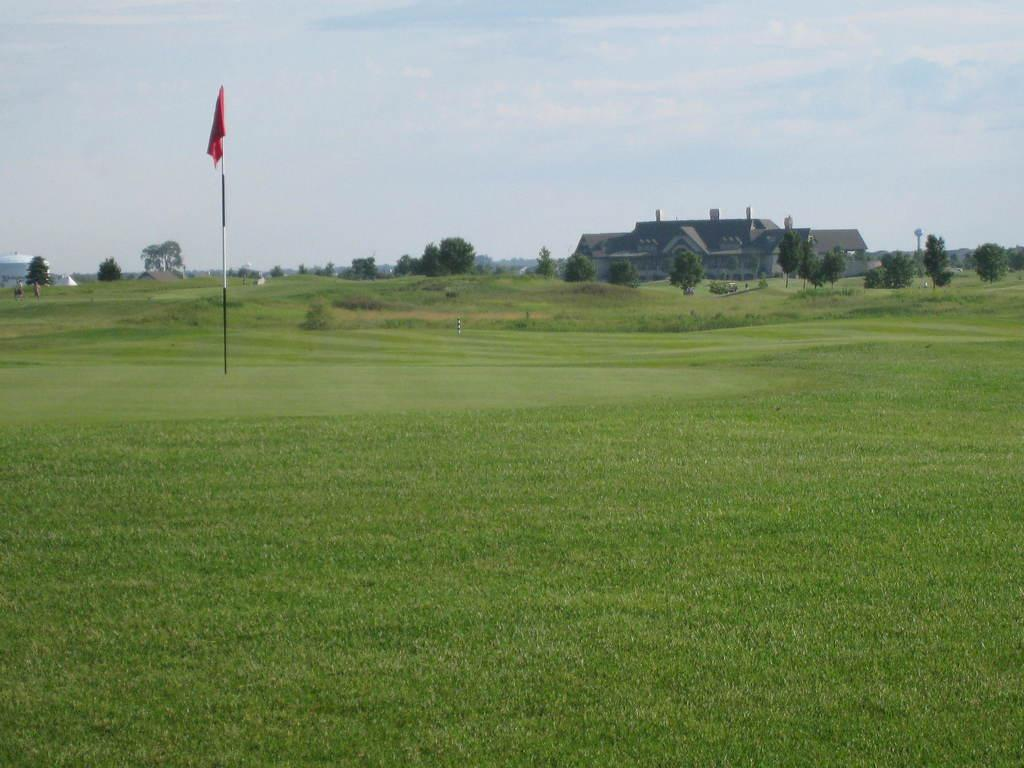What type of vegetation is present in the image? There is grass in the image. What is attached to the pole in the image? There is a flag attached to the pole in the image. What other natural elements can be seen in the image? There are trees in the image. What type of structure is visible in the image? There is a building in the image. Can you describe the objects in the image? There are some objects in the image, but their specific details are not mentioned in the facts. What is visible in the background of the image? The sky is visible in the background of the image, and there are clouds in the sky. What does the dad say about the beef in the image? There is no mention of a dad or beef in the image, so this question cannot be answered. 